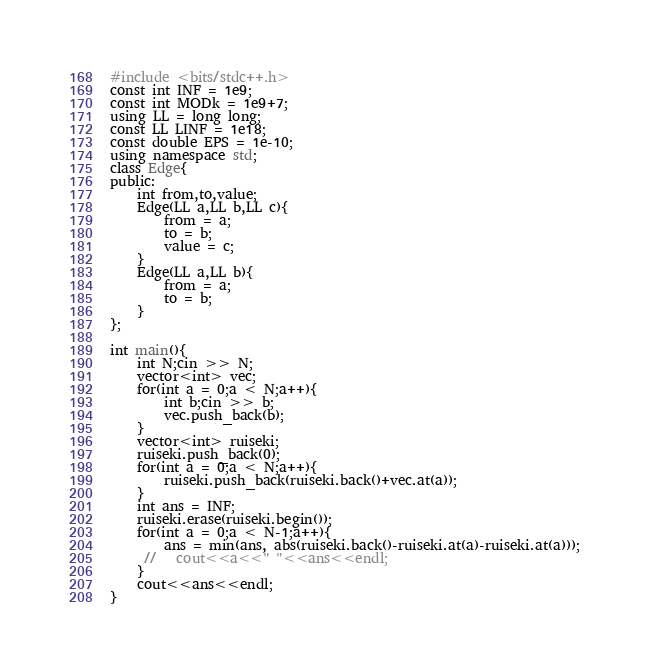Convert code to text. <code><loc_0><loc_0><loc_500><loc_500><_C++_>#include <bits/stdc++.h>
const int INF = 1e9;
const int MODk = 1e9+7;
using LL = long long;
const LL LINF = 1e18;
const double EPS = 1e-10;
using namespace std;
class Edge{
public:
    int from,to,value;
    Edge(LL a,LL b,LL c){
        from = a;
        to = b;
        value = c;
    }
    Edge(LL a,LL b){
        from = a;
        to = b;
    }
};

int main(){
    int N;cin >> N;
    vector<int> vec;
    for(int a = 0;a < N;a++){
        int b;cin >> b;
        vec.push_back(b);
    }
    vector<int> ruiseki;
    ruiseki.push_back(0);
    for(int a = 0;a < N;a++){
        ruiseki.push_back(ruiseki.back()+vec.at(a));
    }
    int ans = INF;
    ruiseki.erase(ruiseki.begin());
    for(int a = 0;a < N-1;a++){
        ans = min(ans, abs(ruiseki.back()-ruiseki.at(a)-ruiseki.at(a)));
     //   cout<<a<<" "<<ans<<endl;
    }
    cout<<ans<<endl;
}
</code> 